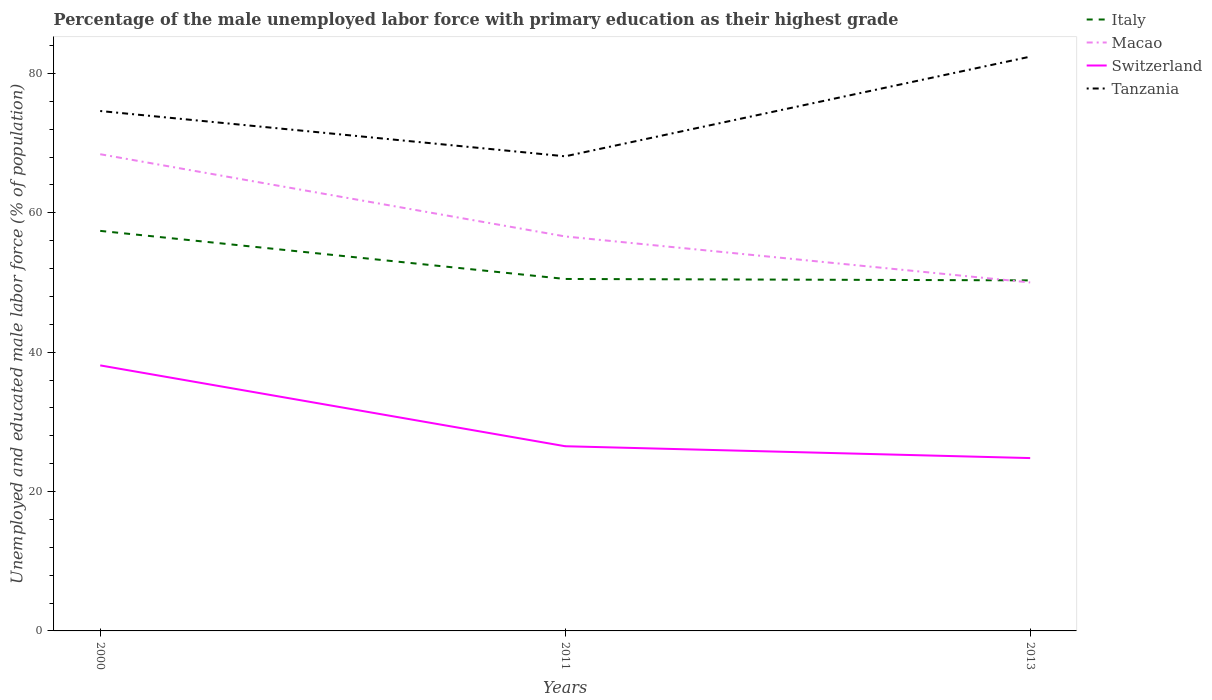How many different coloured lines are there?
Make the answer very short. 4. Does the line corresponding to Tanzania intersect with the line corresponding to Switzerland?
Provide a succinct answer. No. Across all years, what is the maximum percentage of the unemployed male labor force with primary education in Switzerland?
Provide a short and direct response. 24.8. In which year was the percentage of the unemployed male labor force with primary education in Italy maximum?
Offer a very short reply. 2013. What is the total percentage of the unemployed male labor force with primary education in Macao in the graph?
Offer a terse response. 6.6. What is the difference between the highest and the second highest percentage of the unemployed male labor force with primary education in Tanzania?
Make the answer very short. 14.3. What is the difference between the highest and the lowest percentage of the unemployed male labor force with primary education in Switzerland?
Your answer should be compact. 1. Is the percentage of the unemployed male labor force with primary education in Italy strictly greater than the percentage of the unemployed male labor force with primary education in Tanzania over the years?
Provide a succinct answer. Yes. How many lines are there?
Your answer should be very brief. 4. How many years are there in the graph?
Keep it short and to the point. 3. Does the graph contain grids?
Provide a succinct answer. No. Where does the legend appear in the graph?
Offer a very short reply. Top right. What is the title of the graph?
Your answer should be compact. Percentage of the male unemployed labor force with primary education as their highest grade. Does "Montenegro" appear as one of the legend labels in the graph?
Your answer should be very brief. No. What is the label or title of the Y-axis?
Your answer should be very brief. Unemployed and educated male labor force (% of population). What is the Unemployed and educated male labor force (% of population) in Italy in 2000?
Make the answer very short. 57.4. What is the Unemployed and educated male labor force (% of population) of Macao in 2000?
Your response must be concise. 68.4. What is the Unemployed and educated male labor force (% of population) of Switzerland in 2000?
Offer a very short reply. 38.1. What is the Unemployed and educated male labor force (% of population) in Tanzania in 2000?
Give a very brief answer. 74.6. What is the Unemployed and educated male labor force (% of population) of Italy in 2011?
Provide a short and direct response. 50.5. What is the Unemployed and educated male labor force (% of population) in Macao in 2011?
Ensure brevity in your answer.  56.6. What is the Unemployed and educated male labor force (% of population) of Tanzania in 2011?
Give a very brief answer. 68.1. What is the Unemployed and educated male labor force (% of population) in Italy in 2013?
Offer a very short reply. 50.3. What is the Unemployed and educated male labor force (% of population) in Macao in 2013?
Offer a terse response. 50. What is the Unemployed and educated male labor force (% of population) in Switzerland in 2013?
Provide a succinct answer. 24.8. What is the Unemployed and educated male labor force (% of population) in Tanzania in 2013?
Give a very brief answer. 82.4. Across all years, what is the maximum Unemployed and educated male labor force (% of population) in Italy?
Offer a terse response. 57.4. Across all years, what is the maximum Unemployed and educated male labor force (% of population) in Macao?
Provide a succinct answer. 68.4. Across all years, what is the maximum Unemployed and educated male labor force (% of population) of Switzerland?
Give a very brief answer. 38.1. Across all years, what is the maximum Unemployed and educated male labor force (% of population) of Tanzania?
Keep it short and to the point. 82.4. Across all years, what is the minimum Unemployed and educated male labor force (% of population) of Italy?
Make the answer very short. 50.3. Across all years, what is the minimum Unemployed and educated male labor force (% of population) of Switzerland?
Your answer should be very brief. 24.8. Across all years, what is the minimum Unemployed and educated male labor force (% of population) in Tanzania?
Your response must be concise. 68.1. What is the total Unemployed and educated male labor force (% of population) of Italy in the graph?
Your answer should be very brief. 158.2. What is the total Unemployed and educated male labor force (% of population) of Macao in the graph?
Your answer should be compact. 175. What is the total Unemployed and educated male labor force (% of population) in Switzerland in the graph?
Your response must be concise. 89.4. What is the total Unemployed and educated male labor force (% of population) in Tanzania in the graph?
Give a very brief answer. 225.1. What is the difference between the Unemployed and educated male labor force (% of population) in Switzerland in 2000 and that in 2011?
Keep it short and to the point. 11.6. What is the difference between the Unemployed and educated male labor force (% of population) of Italy in 2000 and that in 2013?
Offer a very short reply. 7.1. What is the difference between the Unemployed and educated male labor force (% of population) in Tanzania in 2000 and that in 2013?
Give a very brief answer. -7.8. What is the difference between the Unemployed and educated male labor force (% of population) in Italy in 2011 and that in 2013?
Offer a terse response. 0.2. What is the difference between the Unemployed and educated male labor force (% of population) of Tanzania in 2011 and that in 2013?
Offer a terse response. -14.3. What is the difference between the Unemployed and educated male labor force (% of population) of Italy in 2000 and the Unemployed and educated male labor force (% of population) of Macao in 2011?
Provide a succinct answer. 0.8. What is the difference between the Unemployed and educated male labor force (% of population) of Italy in 2000 and the Unemployed and educated male labor force (% of population) of Switzerland in 2011?
Offer a terse response. 30.9. What is the difference between the Unemployed and educated male labor force (% of population) in Macao in 2000 and the Unemployed and educated male labor force (% of population) in Switzerland in 2011?
Ensure brevity in your answer.  41.9. What is the difference between the Unemployed and educated male labor force (% of population) in Switzerland in 2000 and the Unemployed and educated male labor force (% of population) in Tanzania in 2011?
Provide a short and direct response. -30. What is the difference between the Unemployed and educated male labor force (% of population) in Italy in 2000 and the Unemployed and educated male labor force (% of population) in Macao in 2013?
Provide a short and direct response. 7.4. What is the difference between the Unemployed and educated male labor force (% of population) of Italy in 2000 and the Unemployed and educated male labor force (% of population) of Switzerland in 2013?
Ensure brevity in your answer.  32.6. What is the difference between the Unemployed and educated male labor force (% of population) in Italy in 2000 and the Unemployed and educated male labor force (% of population) in Tanzania in 2013?
Your answer should be compact. -25. What is the difference between the Unemployed and educated male labor force (% of population) in Macao in 2000 and the Unemployed and educated male labor force (% of population) in Switzerland in 2013?
Make the answer very short. 43.6. What is the difference between the Unemployed and educated male labor force (% of population) in Macao in 2000 and the Unemployed and educated male labor force (% of population) in Tanzania in 2013?
Offer a very short reply. -14. What is the difference between the Unemployed and educated male labor force (% of population) of Switzerland in 2000 and the Unemployed and educated male labor force (% of population) of Tanzania in 2013?
Offer a very short reply. -44.3. What is the difference between the Unemployed and educated male labor force (% of population) of Italy in 2011 and the Unemployed and educated male labor force (% of population) of Switzerland in 2013?
Your answer should be compact. 25.7. What is the difference between the Unemployed and educated male labor force (% of population) of Italy in 2011 and the Unemployed and educated male labor force (% of population) of Tanzania in 2013?
Keep it short and to the point. -31.9. What is the difference between the Unemployed and educated male labor force (% of population) of Macao in 2011 and the Unemployed and educated male labor force (% of population) of Switzerland in 2013?
Keep it short and to the point. 31.8. What is the difference between the Unemployed and educated male labor force (% of population) of Macao in 2011 and the Unemployed and educated male labor force (% of population) of Tanzania in 2013?
Provide a succinct answer. -25.8. What is the difference between the Unemployed and educated male labor force (% of population) of Switzerland in 2011 and the Unemployed and educated male labor force (% of population) of Tanzania in 2013?
Offer a terse response. -55.9. What is the average Unemployed and educated male labor force (% of population) of Italy per year?
Provide a succinct answer. 52.73. What is the average Unemployed and educated male labor force (% of population) in Macao per year?
Provide a short and direct response. 58.33. What is the average Unemployed and educated male labor force (% of population) of Switzerland per year?
Offer a very short reply. 29.8. What is the average Unemployed and educated male labor force (% of population) of Tanzania per year?
Keep it short and to the point. 75.03. In the year 2000, what is the difference between the Unemployed and educated male labor force (% of population) of Italy and Unemployed and educated male labor force (% of population) of Macao?
Keep it short and to the point. -11. In the year 2000, what is the difference between the Unemployed and educated male labor force (% of population) in Italy and Unemployed and educated male labor force (% of population) in Switzerland?
Keep it short and to the point. 19.3. In the year 2000, what is the difference between the Unemployed and educated male labor force (% of population) in Italy and Unemployed and educated male labor force (% of population) in Tanzania?
Keep it short and to the point. -17.2. In the year 2000, what is the difference between the Unemployed and educated male labor force (% of population) in Macao and Unemployed and educated male labor force (% of population) in Switzerland?
Provide a short and direct response. 30.3. In the year 2000, what is the difference between the Unemployed and educated male labor force (% of population) in Switzerland and Unemployed and educated male labor force (% of population) in Tanzania?
Make the answer very short. -36.5. In the year 2011, what is the difference between the Unemployed and educated male labor force (% of population) in Italy and Unemployed and educated male labor force (% of population) in Tanzania?
Ensure brevity in your answer.  -17.6. In the year 2011, what is the difference between the Unemployed and educated male labor force (% of population) in Macao and Unemployed and educated male labor force (% of population) in Switzerland?
Provide a succinct answer. 30.1. In the year 2011, what is the difference between the Unemployed and educated male labor force (% of population) in Macao and Unemployed and educated male labor force (% of population) in Tanzania?
Offer a terse response. -11.5. In the year 2011, what is the difference between the Unemployed and educated male labor force (% of population) of Switzerland and Unemployed and educated male labor force (% of population) of Tanzania?
Provide a short and direct response. -41.6. In the year 2013, what is the difference between the Unemployed and educated male labor force (% of population) of Italy and Unemployed and educated male labor force (% of population) of Macao?
Make the answer very short. 0.3. In the year 2013, what is the difference between the Unemployed and educated male labor force (% of population) in Italy and Unemployed and educated male labor force (% of population) in Switzerland?
Ensure brevity in your answer.  25.5. In the year 2013, what is the difference between the Unemployed and educated male labor force (% of population) in Italy and Unemployed and educated male labor force (% of population) in Tanzania?
Your response must be concise. -32.1. In the year 2013, what is the difference between the Unemployed and educated male labor force (% of population) in Macao and Unemployed and educated male labor force (% of population) in Switzerland?
Ensure brevity in your answer.  25.2. In the year 2013, what is the difference between the Unemployed and educated male labor force (% of population) in Macao and Unemployed and educated male labor force (% of population) in Tanzania?
Provide a succinct answer. -32.4. In the year 2013, what is the difference between the Unemployed and educated male labor force (% of population) of Switzerland and Unemployed and educated male labor force (% of population) of Tanzania?
Your response must be concise. -57.6. What is the ratio of the Unemployed and educated male labor force (% of population) of Italy in 2000 to that in 2011?
Offer a very short reply. 1.14. What is the ratio of the Unemployed and educated male labor force (% of population) of Macao in 2000 to that in 2011?
Provide a short and direct response. 1.21. What is the ratio of the Unemployed and educated male labor force (% of population) of Switzerland in 2000 to that in 2011?
Give a very brief answer. 1.44. What is the ratio of the Unemployed and educated male labor force (% of population) in Tanzania in 2000 to that in 2011?
Keep it short and to the point. 1.1. What is the ratio of the Unemployed and educated male labor force (% of population) in Italy in 2000 to that in 2013?
Offer a very short reply. 1.14. What is the ratio of the Unemployed and educated male labor force (% of population) of Macao in 2000 to that in 2013?
Make the answer very short. 1.37. What is the ratio of the Unemployed and educated male labor force (% of population) in Switzerland in 2000 to that in 2013?
Offer a very short reply. 1.54. What is the ratio of the Unemployed and educated male labor force (% of population) in Tanzania in 2000 to that in 2013?
Your answer should be very brief. 0.91. What is the ratio of the Unemployed and educated male labor force (% of population) of Macao in 2011 to that in 2013?
Offer a very short reply. 1.13. What is the ratio of the Unemployed and educated male labor force (% of population) of Switzerland in 2011 to that in 2013?
Provide a short and direct response. 1.07. What is the ratio of the Unemployed and educated male labor force (% of population) in Tanzania in 2011 to that in 2013?
Your answer should be compact. 0.83. What is the difference between the highest and the second highest Unemployed and educated male labor force (% of population) in Macao?
Provide a succinct answer. 11.8. What is the difference between the highest and the lowest Unemployed and educated male labor force (% of population) of Italy?
Your response must be concise. 7.1. What is the difference between the highest and the lowest Unemployed and educated male labor force (% of population) in Macao?
Offer a terse response. 18.4. 